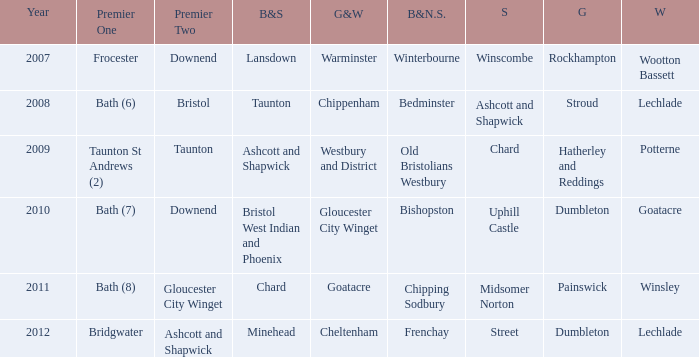What is the latest year where glos & wilts is warminster? 2007.0. 